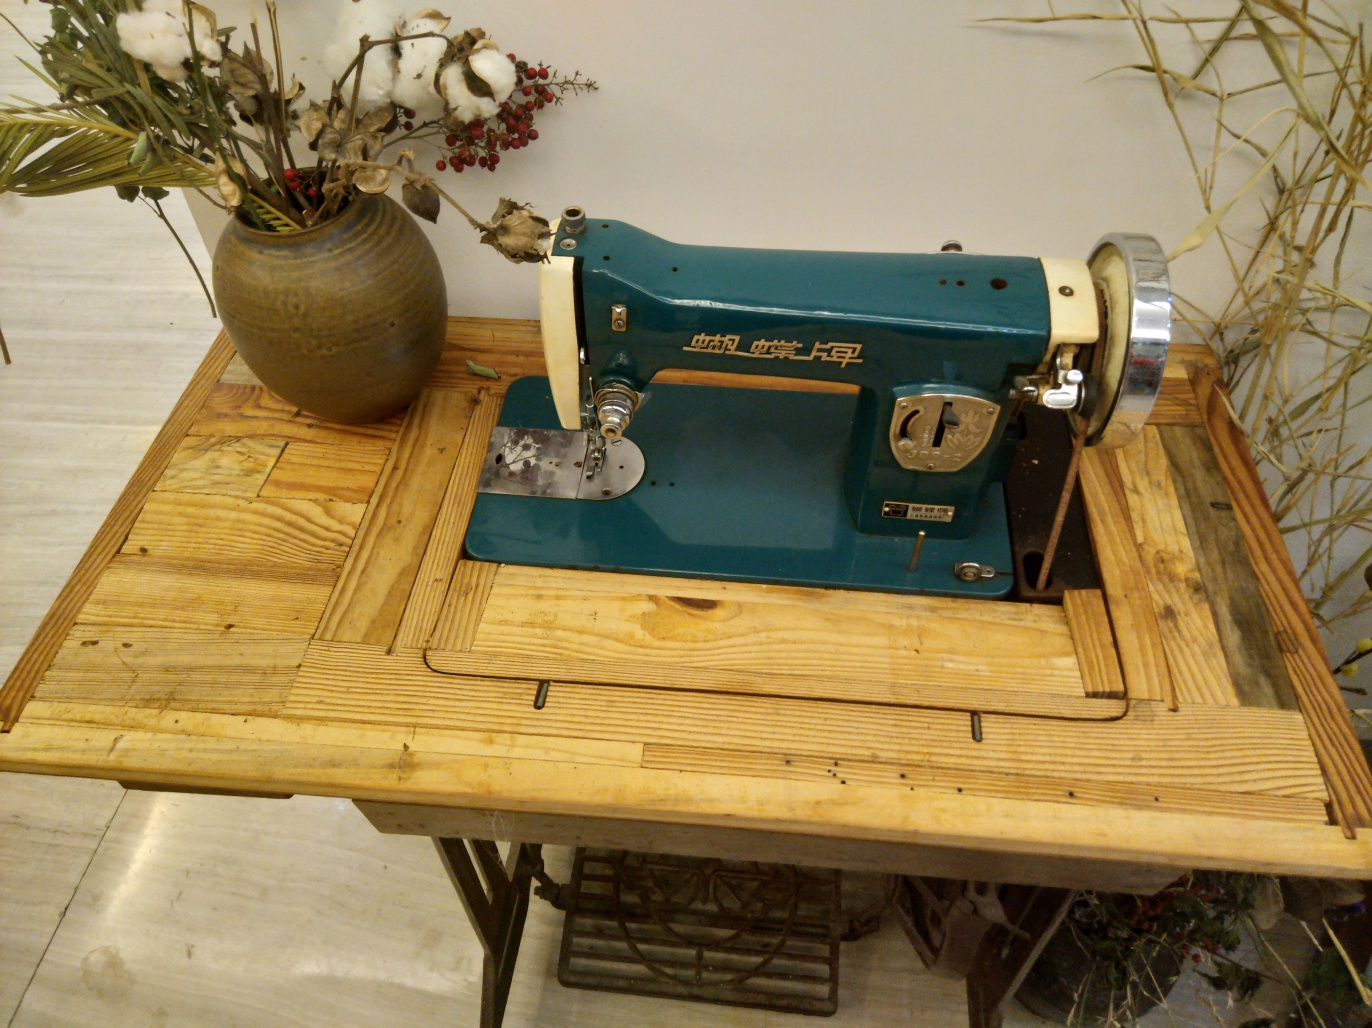Are the details of the cotton and bamboo leaves in the background rich? Yes, the details of the cotton and bamboo leaves are quite rich, which adds a touch of natural authenticity to the setting. The textures of the cotton fibers and the leaves can be seen clearly, creating a visually appealing contrast with the rustic wooden table and the vintage sewing machine. 